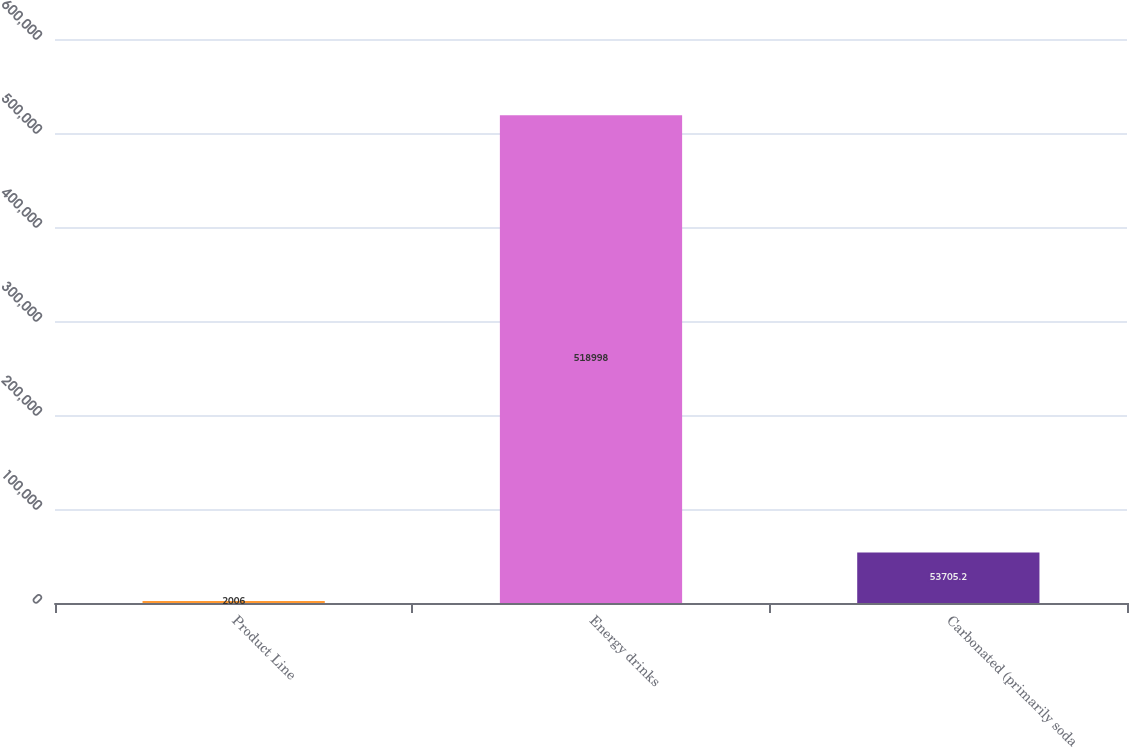Convert chart. <chart><loc_0><loc_0><loc_500><loc_500><bar_chart><fcel>Product Line<fcel>Energy drinks<fcel>Carbonated (primarily soda<nl><fcel>2006<fcel>518998<fcel>53705.2<nl></chart> 